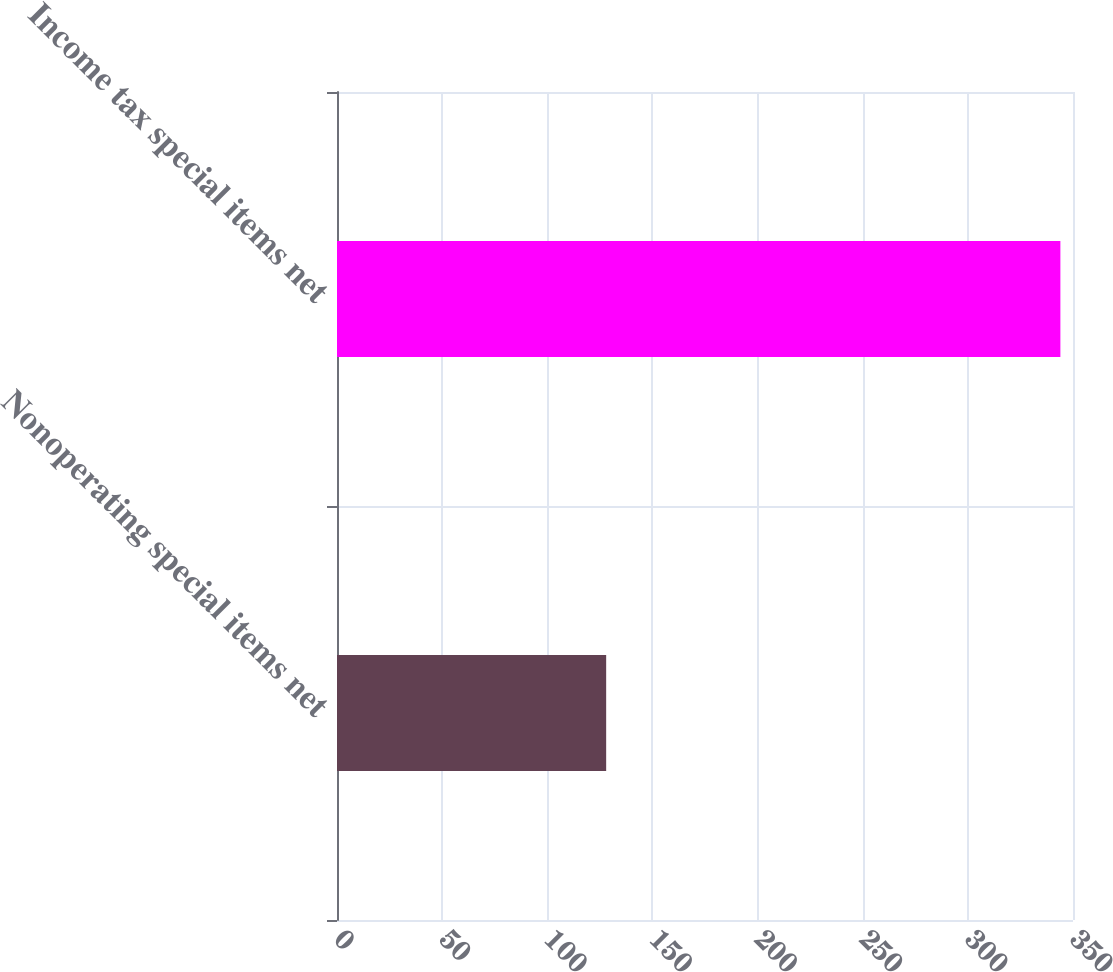Convert chart to OTSL. <chart><loc_0><loc_0><loc_500><loc_500><bar_chart><fcel>Nonoperating special items net<fcel>Income tax special items net<nl><fcel>128<fcel>344<nl></chart> 